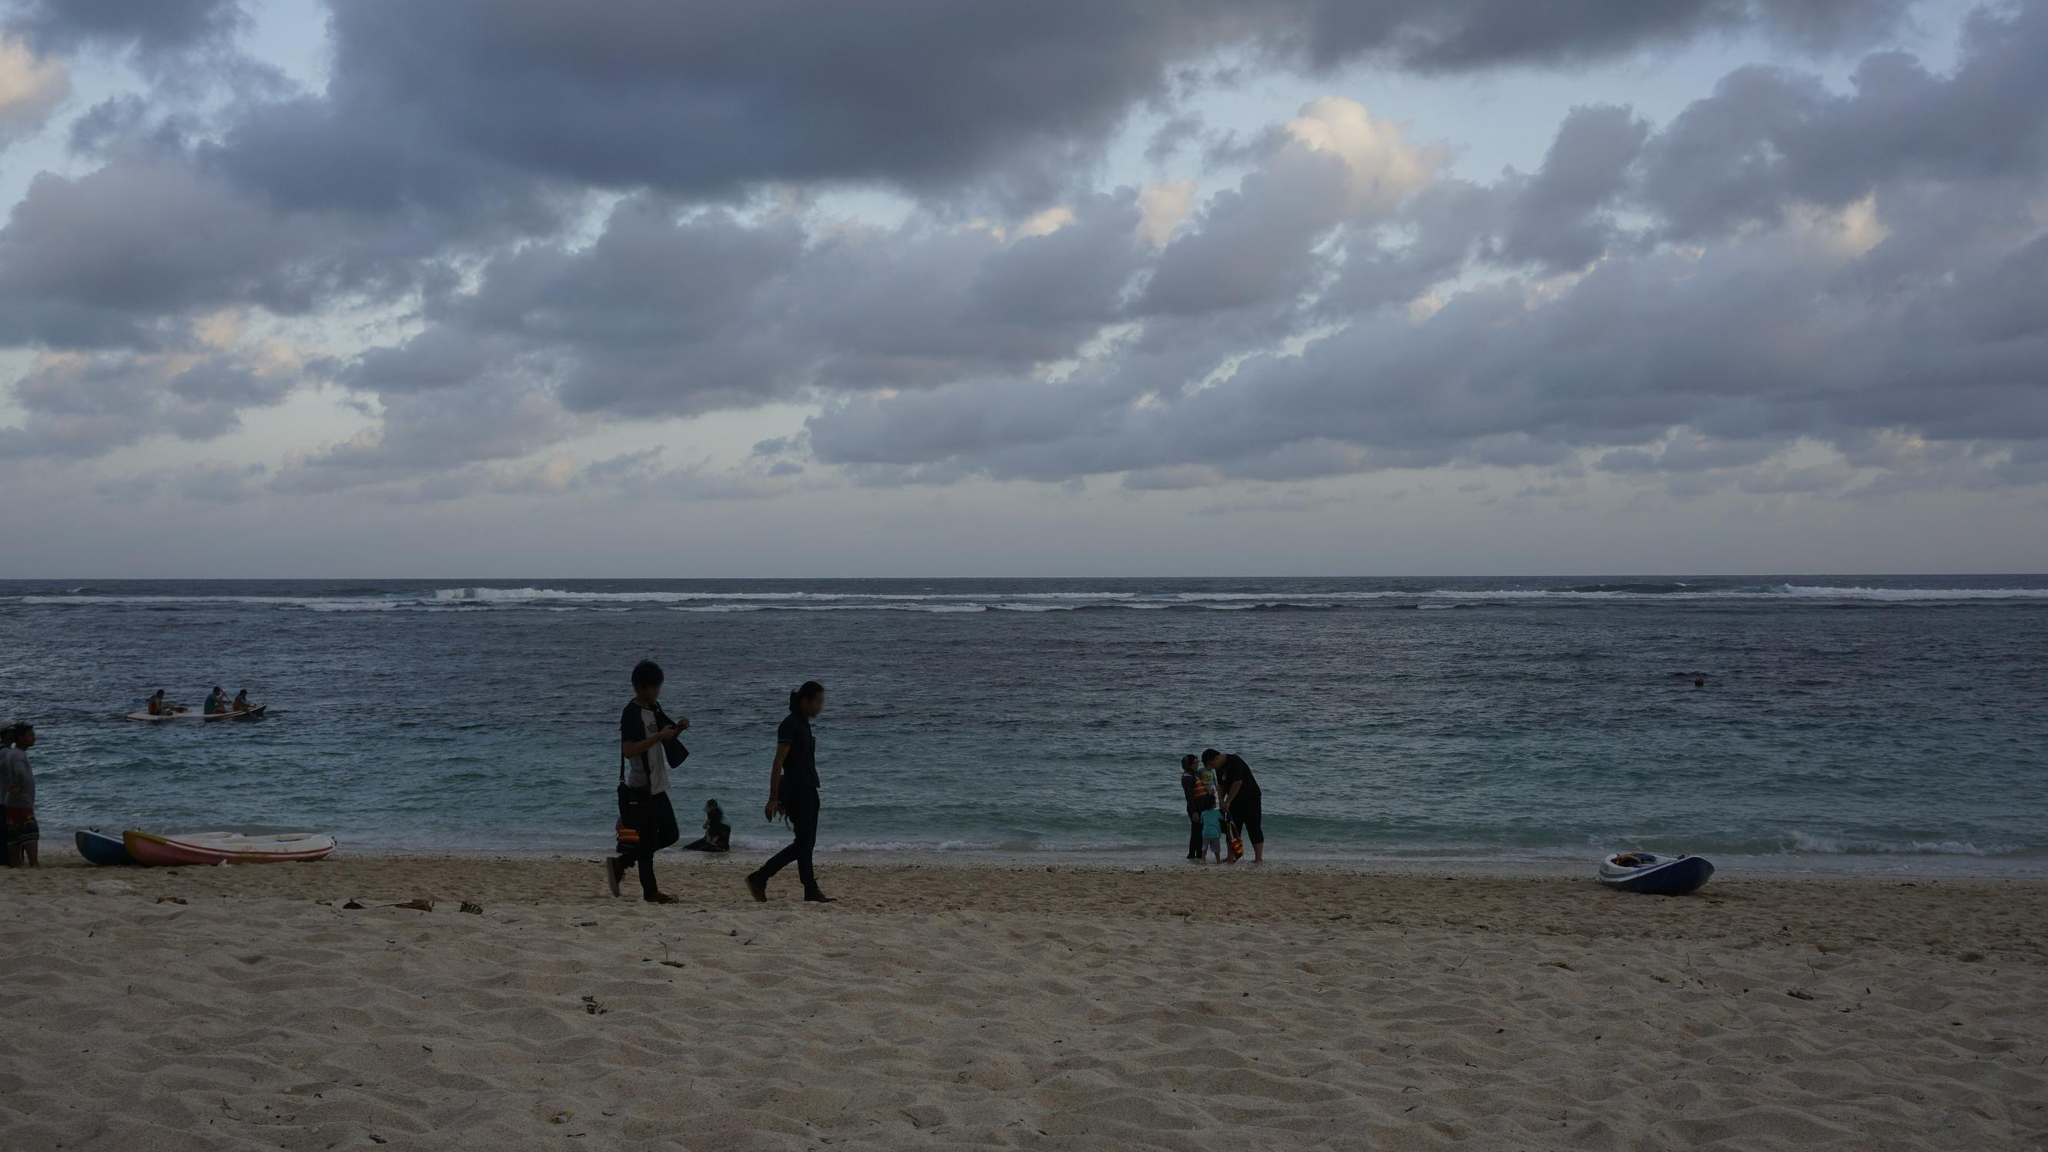What kind of activities do you think people are enjoying at the beach? The people at the beach appear to be engaged in various recreational activities. Some are taking a leisurely stroll along the shore, enjoying the gentle sea breeze. Others can be seen in the water, possibly kayaking or swimming, making the best of the calm sea conditions. On the sand, there are families and individuals relaxing, perhaps building sandcastles, playing beach games, or simply soaking in the serene seaside environment. What time of day might this scene depict? Judging by the relatively dim light and the presence of an overcast sky, this scene could be set either in the early morning, right after sunrise, or late afternoon as the day is winding down. The soft, subdued lighting and the calm, leisurely activities of the people suggest a time of day that is peaceful and not too crowded, likely when temperatures are milder. Invent a humorous story that might be happening behind the scenes. Sure! Here’s a humorous take: Amidst the tranquil beachgoers, a seagull heist is unfolding. A group of seagulls, led by their ringleader 'Captain Beaky,' have concocted a master plan to snatch up all the unattended snacks. Their mission is to disrupt the peace by dive-bombing picnic spots and swooping down to steal sandwiches, chips, and cookies. Unbeknownst to them, a sneaky crab, named 'Pinchy,' is gathering intel and plotting to foil their plan, hoping to become the beach's unsung hero. As the humans relax, oblivious to the feathered mayhem, the scene is set for an epic showdown between the crafty seagulls and the brave little crab with dreams of grandeur! 